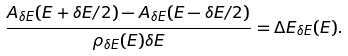<formula> <loc_0><loc_0><loc_500><loc_500>\frac { A _ { \delta E } ( E + \delta E / 2 ) - A _ { \delta E } ( E - \delta E / 2 ) } { \rho _ { \delta E } ( E ) \delta E } = \Delta E _ { \delta E } ( E ) .</formula> 